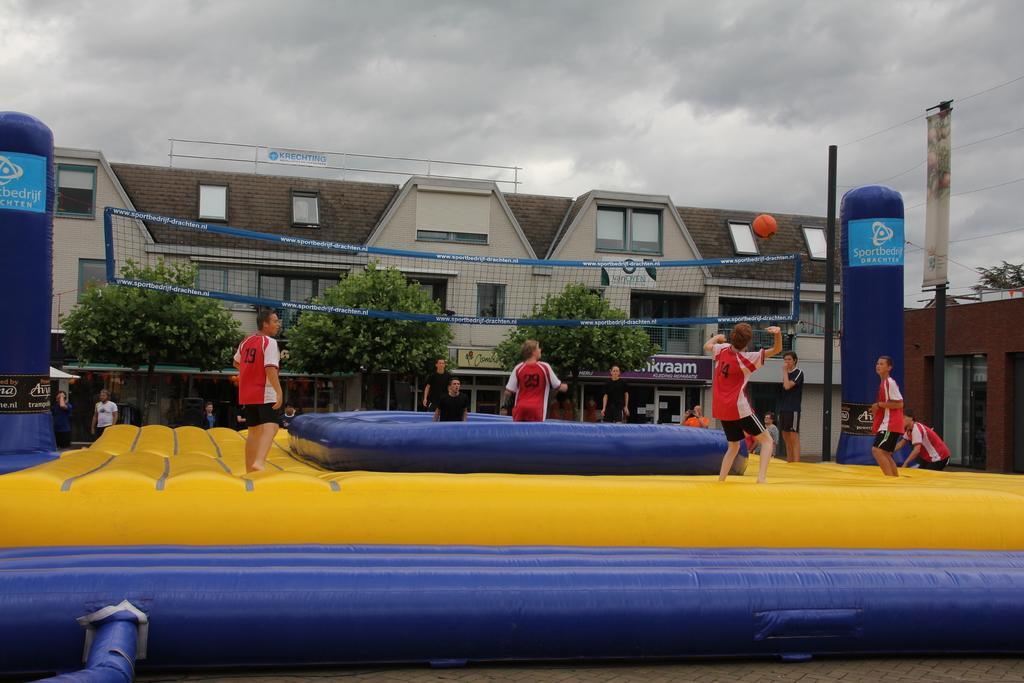What is the person in the image trying to do? The person in the image is trying to hit a ball. Are there any other people present in the image? Yes, there are other people standing in the image. What is separating the two sides in the image? There is a net in the image. What type of natural environment is visible in the image? There are trees in the image. What type of structure is visible in the image? There is a building in the image. What is visible in the sky in the image? The sky is visible in the image. What type of game are the cows playing in the image? There are no cows present in the image, so it is not possible to determine what game they might be playing. 